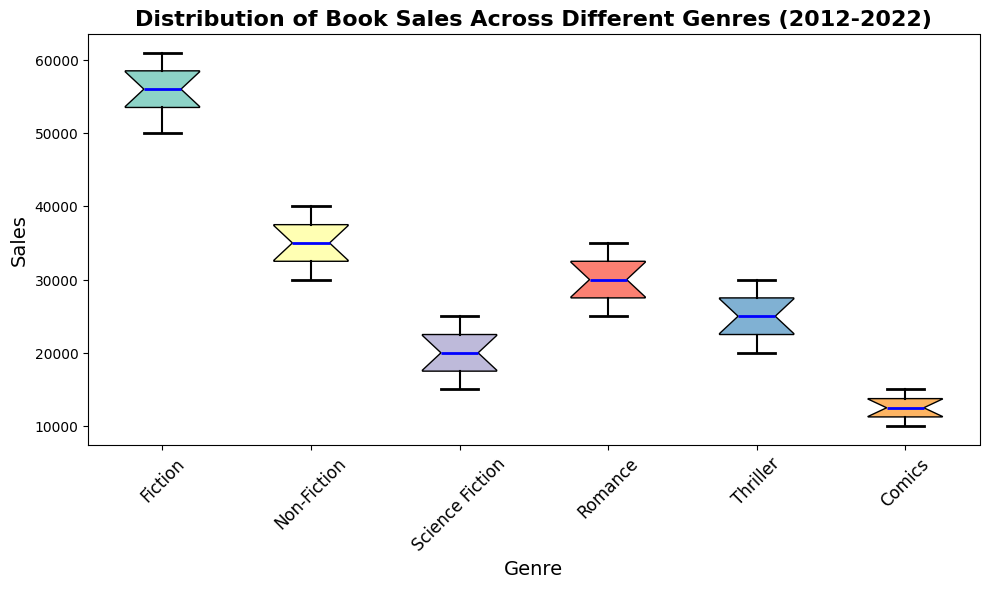What's the median sales value for Fiction books? The median is the middle value of the sorted sales data for Fiction books. The sales data are: 50000, 52000, 53000, 54000, 55000, 56000, 57000, 58000, 59000, 60000, 61000. The median value, the 6th value in this sorted list, is 56000.
Answer: 56000 Which genre has the highest median sales value? The box plot displays the median sales values for each genre. Fiction has the highest median sales value, as its central line is the highest among all genres.
Answer: Fiction What is the interquartile range (IQR) for Comics sales? The IQR is the range between the first quartile (Q1) and the third quartile (Q3). In the box plot, these are the lower and upper edges of the box. From observation, Q1 (10,000) and Q3 (15,000) for Comics. Thus, IQR = 15,000 - 10,000 = 5,000.
Answer: 5000 Which genre shows the most consistent sales over the decade? Consistency can be inferred from the shortest box length in the box plot, indicating low variability. Non-Fiction has the shortest box, signifying the most consistent sales.
Answer: Non-Fiction Are there any outliers in the Thriller genre's sales? Outliers are points outside the whiskers of the box plot, represented by red circles. In the box plot, there are no red circles for Thriller, indicating no outliers.
Answer: No What is the total sales increment for Romance books from 2012 to 2022? To find the total increment, subtract the 2012 value from the 2022 value for Romance: 35,000 (2022) - 25,000 (2012) = 10,000.
Answer: 10000 How do the sales of Science Fiction compare to Comics in terms of their medians? By comparing the central line within the boxes for Science Fiction and Comics, it is clear that the median sales for Science Fiction are greater than for Comics.
Answer: Science Fiction > Comics Which genre's sales saw the largest increase in the median from the lower quartile to the upper quartile? The largest increase is observed by identifying the genre with the longest box length. Fiction has the longest box, indicating the largest increase.
Answer: Fiction What is the whisker length for Romance sales, and what does it indicate? The whisker length indicates the range of non-outlier data, extending from the minimum to maximum values within 1.5 times the interquartile range. For Romance, whiskers extend from approximately 25,000 to 35,000, indicating the range.
Answer: ~10000 Do any genres have a median value that intersects with the third quartile of Non-Fiction sales? By analyzing the third quartile of Non-Fiction sales, approximately 40,000, and comparing them with medians of other genres, we see that no other genre’s median intersects with the third quartile of Non-Fiction sales.
Answer: No 